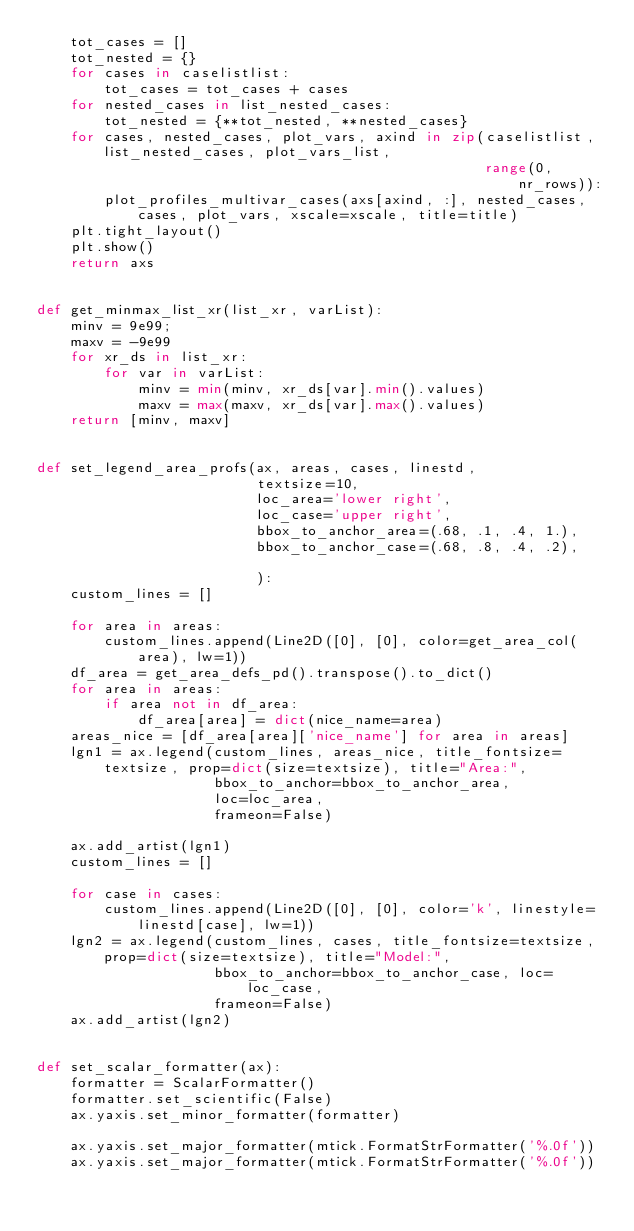Convert code to text. <code><loc_0><loc_0><loc_500><loc_500><_Python_>    tot_cases = []
    tot_nested = {}
    for cases in caselistlist:
        tot_cases = tot_cases + cases
    for nested_cases in list_nested_cases:
        tot_nested = {**tot_nested, **nested_cases}
    for cases, nested_cases, plot_vars, axind in zip(caselistlist, list_nested_cases, plot_vars_list,
                                                     range(0, nr_rows)):
        plot_profiles_multivar_cases(axs[axind, :], nested_cases, cases, plot_vars, xscale=xscale, title=title)
    plt.tight_layout()
    plt.show()
    return axs


def get_minmax_list_xr(list_xr, varList):
    minv = 9e99;
    maxv = -9e99
    for xr_ds in list_xr:
        for var in varList:
            minv = min(minv, xr_ds[var].min().values)
            maxv = max(maxv, xr_ds[var].max().values)
    return [minv, maxv]


def set_legend_area_profs(ax, areas, cases, linestd,
                          textsize=10,
                          loc_area='lower right',
                          loc_case='upper right',
                          bbox_to_anchor_area=(.68, .1, .4, 1.),
                          bbox_to_anchor_case=(.68, .8, .4, .2),

                          ):
    custom_lines = []

    for area in areas:
        custom_lines.append(Line2D([0], [0], color=get_area_col(area), lw=1))
    df_area = get_area_defs_pd().transpose().to_dict()
    for area in areas:
        if area not in df_area:
            df_area[area] = dict(nice_name=area)
    areas_nice = [df_area[area]['nice_name'] for area in areas]
    lgn1 = ax.legend(custom_lines, areas_nice, title_fontsize=textsize, prop=dict(size=textsize), title="Area:",
                     bbox_to_anchor=bbox_to_anchor_area,
                     loc=loc_area,
                     frameon=False)

    ax.add_artist(lgn1)
    custom_lines = []

    for case in cases:
        custom_lines.append(Line2D([0], [0], color='k', linestyle=linestd[case], lw=1))
    lgn2 = ax.legend(custom_lines, cases, title_fontsize=textsize, prop=dict(size=textsize), title="Model:",
                     bbox_to_anchor=bbox_to_anchor_case, loc=loc_case,
                     frameon=False)
    ax.add_artist(lgn2)


def set_scalar_formatter(ax):
    formatter = ScalarFormatter()
    formatter.set_scientific(False)
    ax.yaxis.set_minor_formatter(formatter)

    ax.yaxis.set_major_formatter(mtick.FormatStrFormatter('%.0f'))
    ax.yaxis.set_major_formatter(mtick.FormatStrFormatter('%.0f'))
</code> 